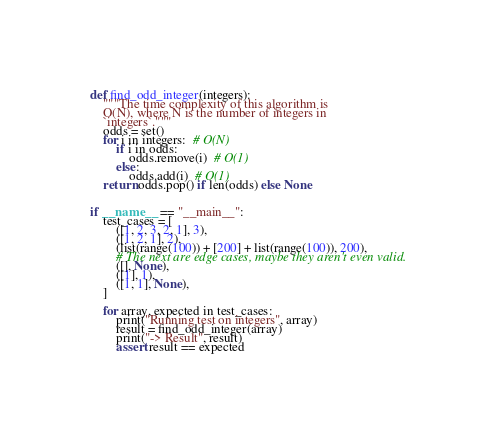Convert code to text. <code><loc_0><loc_0><loc_500><loc_500><_Python_>def find_odd_integer(integers):
    """The time complexity of this algorithm is
    O(N), where N is the number of integers in
    `integers`."""
    odds = set()
    for i in integers:  # O(N)
        if i in odds:
            odds.remove(i)  # O(1)
        else:
            odds.add(i)  # O(1)
    return odds.pop() if len(odds) else None


if __name__ == "__main__":
    test_cases = [
        ([1, 2, 3, 2, 1], 3),
        ([1, 2, 1], 2),
        (list(range(100)) + [200] + list(range(100)), 200),
        # The next are edge cases, maybe they aren't even valid.
        ([], None),
        ([1], 1),
        ([1, 1], None),
    ]

    for array, expected in test_cases:
        print("Running test on integers", array)
        result = find_odd_integer(array)
        print("-> Result", result)
        assert result == expected
</code> 